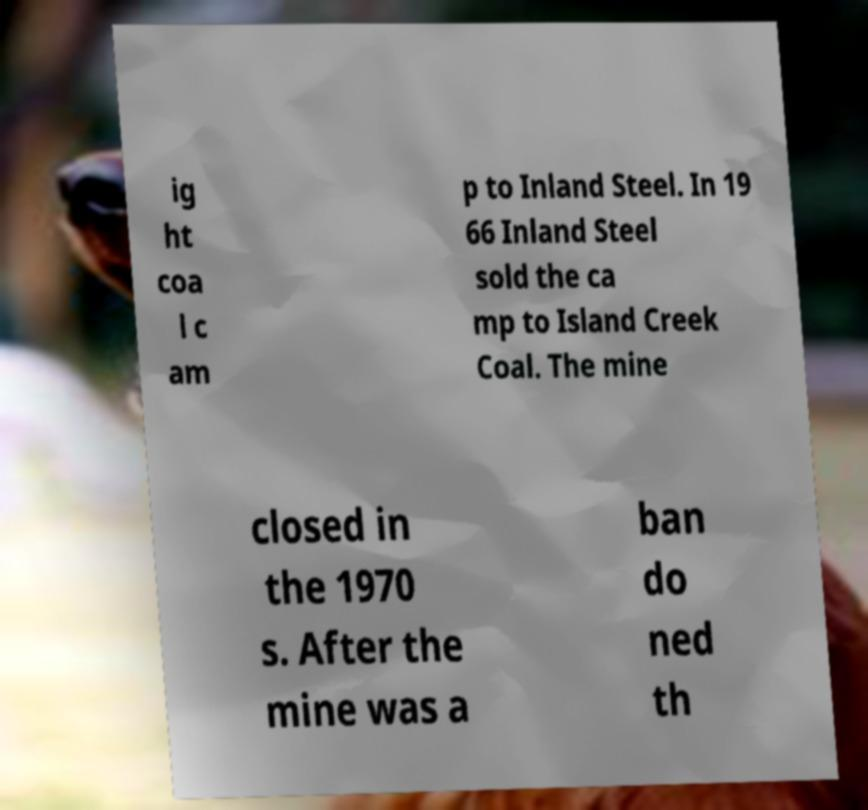Can you read and provide the text displayed in the image?This photo seems to have some interesting text. Can you extract and type it out for me? ig ht coa l c am p to Inland Steel. In 19 66 Inland Steel sold the ca mp to Island Creek Coal. The mine closed in the 1970 s. After the mine was a ban do ned th 